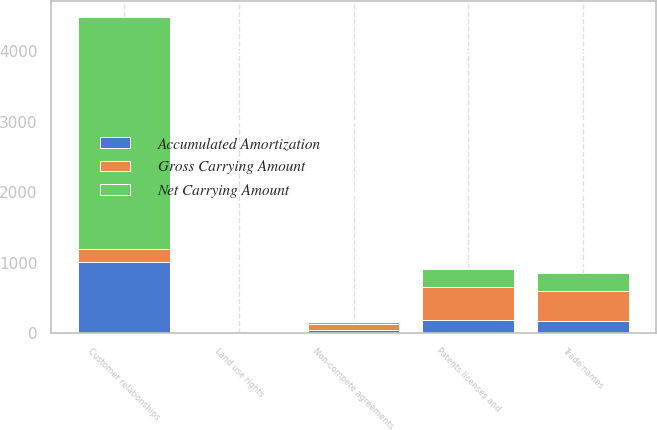Convert chart. <chart><loc_0><loc_0><loc_500><loc_500><stacked_bar_chart><ecel><fcel>Customer relationships<fcel>Patents licenses and<fcel>Non-compete agreements<fcel>Trade names<fcel>Land use rights<nl><fcel>Gross Carrying Amount<fcel>180<fcel>457.9<fcel>79<fcel>426.3<fcel>10.9<nl><fcel>Accumulated Amortization<fcel>1014.9<fcel>188.6<fcel>49.4<fcel>171.4<fcel>2.6<nl><fcel>Net Carrying Amount<fcel>3283<fcel>269.3<fcel>29.6<fcel>254.9<fcel>8.3<nl></chart> 